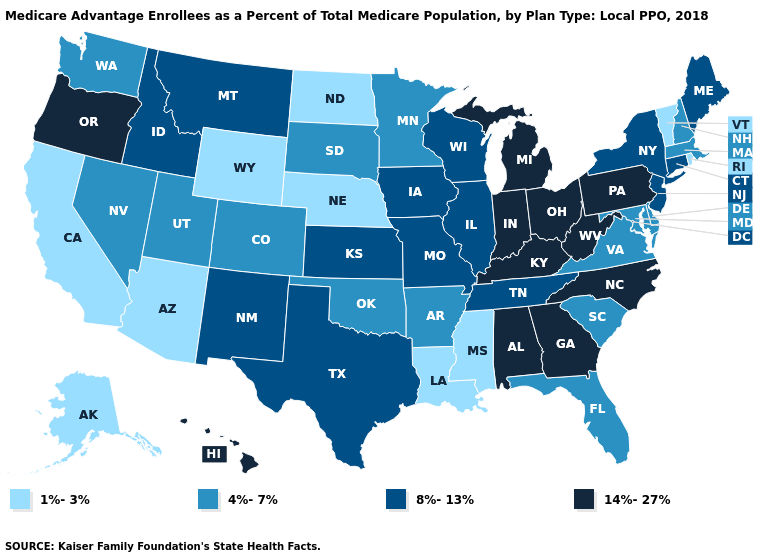What is the value of Connecticut?
Quick response, please. 8%-13%. What is the highest value in states that border West Virginia?
Write a very short answer. 14%-27%. What is the value of North Dakota?
Give a very brief answer. 1%-3%. Does Washington have the lowest value in the USA?
Concise answer only. No. Does Louisiana have the lowest value in the USA?
Keep it brief. Yes. What is the value of Tennessee?
Write a very short answer. 8%-13%. What is the value of Wyoming?
Give a very brief answer. 1%-3%. Does Wyoming have the lowest value in the USA?
Keep it brief. Yes. What is the value of Delaware?
Answer briefly. 4%-7%. Name the states that have a value in the range 8%-13%?
Keep it brief. Connecticut, Idaho, Illinois, Iowa, Kansas, Maine, Missouri, Montana, New Jersey, New Mexico, New York, Tennessee, Texas, Wisconsin. Name the states that have a value in the range 4%-7%?
Give a very brief answer. Arkansas, Colorado, Delaware, Florida, Maryland, Massachusetts, Minnesota, Nevada, New Hampshire, Oklahoma, South Carolina, South Dakota, Utah, Virginia, Washington. Name the states that have a value in the range 14%-27%?
Quick response, please. Alabama, Georgia, Hawaii, Indiana, Kentucky, Michigan, North Carolina, Ohio, Oregon, Pennsylvania, West Virginia. What is the highest value in states that border North Dakota?
Give a very brief answer. 8%-13%. What is the lowest value in states that border Utah?
Concise answer only. 1%-3%. Among the states that border Oklahoma , does Arkansas have the highest value?
Answer briefly. No. 